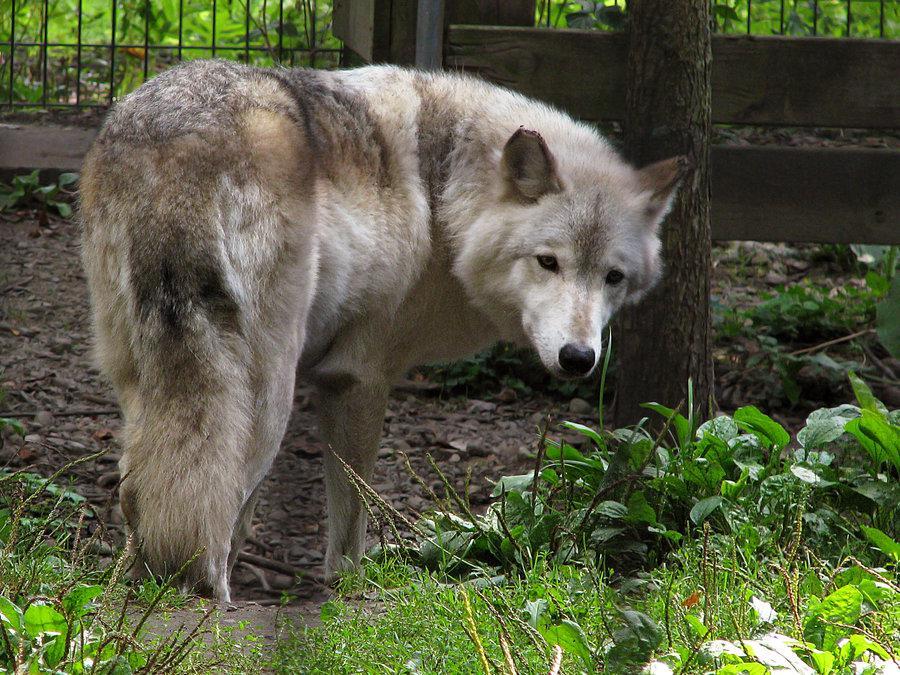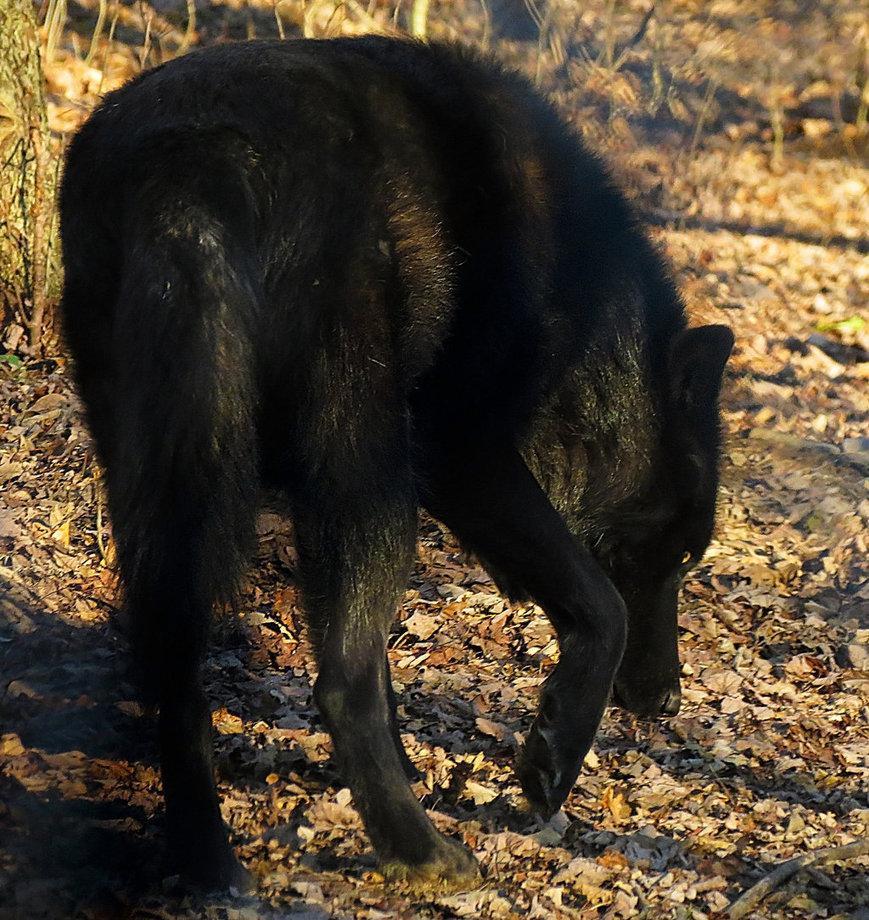The first image is the image on the left, the second image is the image on the right. Considering the images on both sides, is "In the left image, wire fence is visible behind the wolf." valid? Answer yes or no. Yes. The first image is the image on the left, the second image is the image on the right. Examine the images to the left and right. Is the description "There is a fence behind the animal in the image on the left." accurate? Answer yes or no. Yes. 